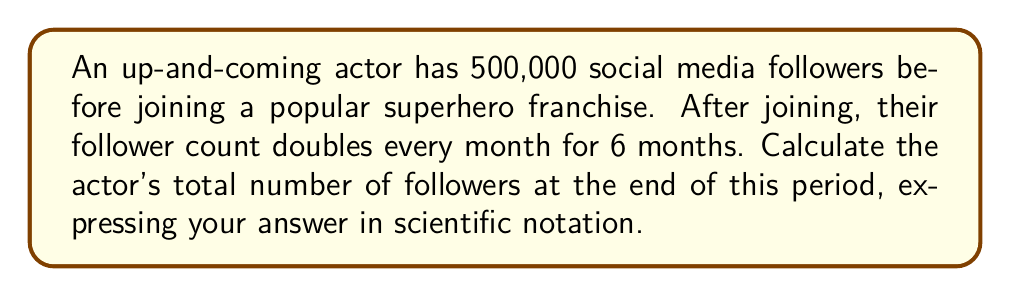Help me with this question. Let's approach this step-by-step:

1) The initial number of followers is 500,000.

2) The follower count doubles every month, which means it's multiplied by 2 each time.

3) This happens for 6 months, so we need to multiply by 2 six times.

4) Mathematically, this can be expressed as:

   $500,000 \times 2^6$

5) Let's calculate $2^6$ first:
   $2^6 = 2 \times 2 \times 2 \times 2 \times 2 \times 2 = 64$

6) Now, we multiply:
   $500,000 \times 64 = 32,000,000$

7) To express this in scientific notation, we move the decimal point 7 places to the left:

   $32,000,000 = 3.2 \times 10^7$

Thus, after 6 months, the actor's follower count will be $3.2 \times 10^7$.
Answer: $3.2 \times 10^7$ 